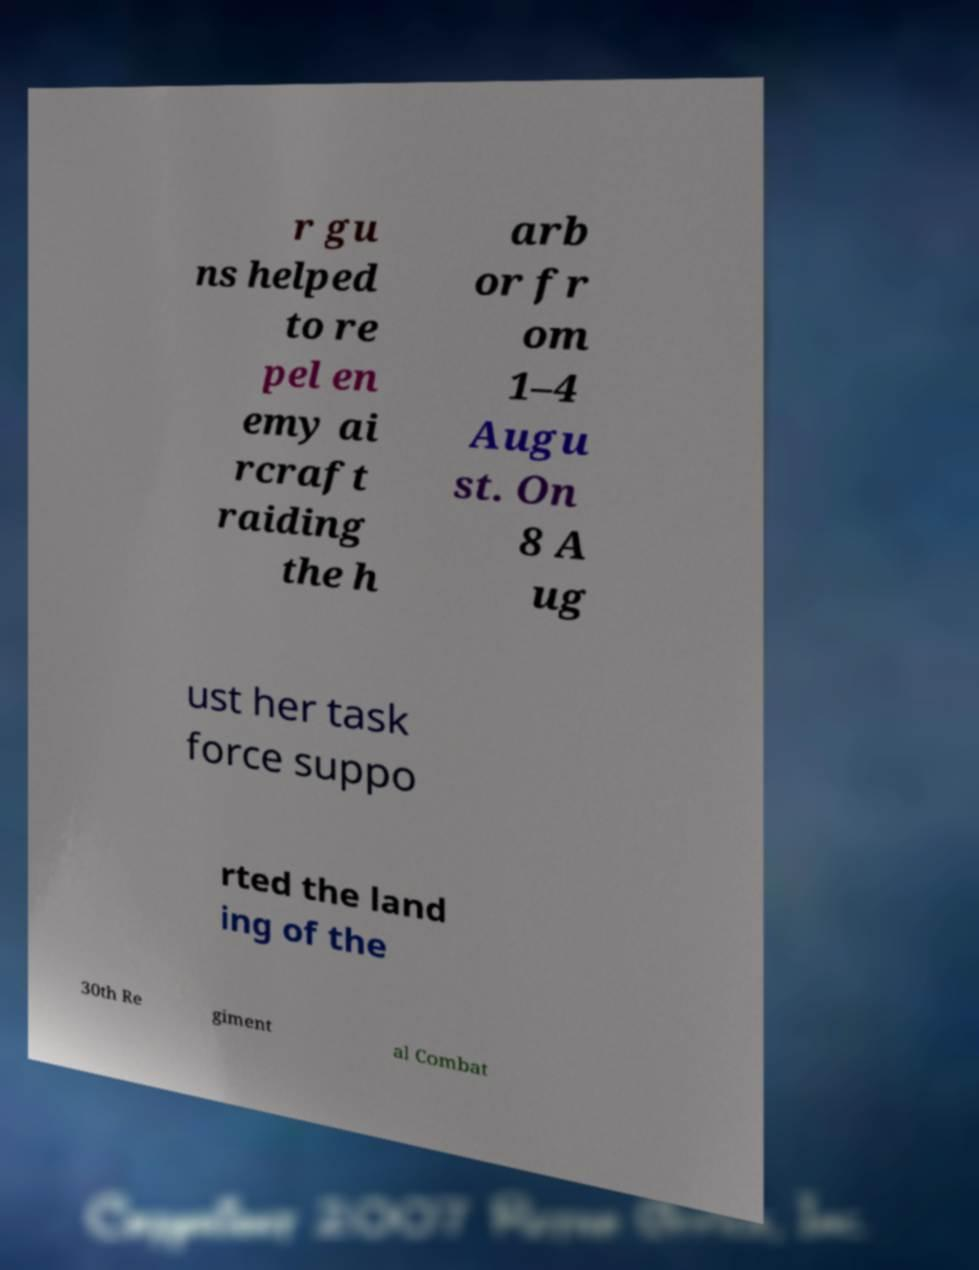There's text embedded in this image that I need extracted. Can you transcribe it verbatim? r gu ns helped to re pel en emy ai rcraft raiding the h arb or fr om 1–4 Augu st. On 8 A ug ust her task force suppo rted the land ing of the 30th Re giment al Combat 